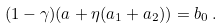<formula> <loc_0><loc_0><loc_500><loc_500>( 1 - \gamma ) ( a + \eta ( a _ { 1 } + a _ { 2 } ) ) = b _ { 0 } \, .</formula> 